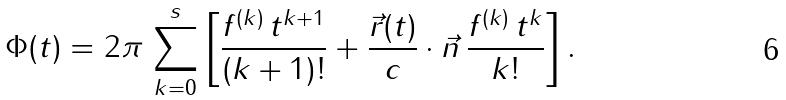<formula> <loc_0><loc_0><loc_500><loc_500>\Phi ( t ) = 2 \pi \, \sum _ { k = 0 } ^ { s } \left [ \frac { f ^ { ( k ) } \, t ^ { k + 1 } } { ( k + 1 ) ! } + \frac { \vec { r } ( t ) } { c } \cdot \vec { n } \, \frac { f ^ { ( k ) } \, t ^ { k } } { k ! } \right ] .</formula> 